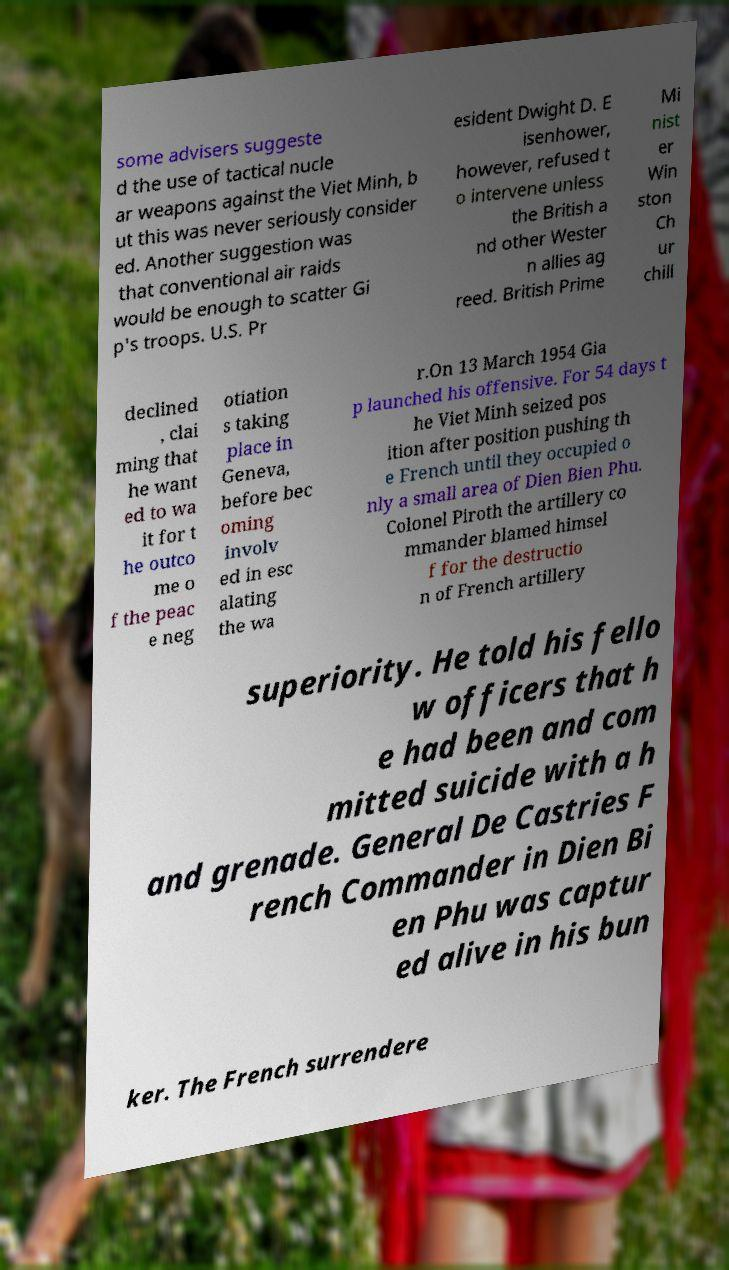What messages or text are displayed in this image? I need them in a readable, typed format. some advisers suggeste d the use of tactical nucle ar weapons against the Viet Minh, b ut this was never seriously consider ed. Another suggestion was that conventional air raids would be enough to scatter Gi p's troops. U.S. Pr esident Dwight D. E isenhower, however, refused t o intervene unless the British a nd other Wester n allies ag reed. British Prime Mi nist er Win ston Ch ur chill declined , clai ming that he want ed to wa it for t he outco me o f the peac e neg otiation s taking place in Geneva, before bec oming involv ed in esc alating the wa r.On 13 March 1954 Gia p launched his offensive. For 54 days t he Viet Minh seized pos ition after position pushing th e French until they occupied o nly a small area of Dien Bien Phu. Colonel Piroth the artillery co mmander blamed himsel f for the destructio n of French artillery superiority. He told his fello w officers that h e had been and com mitted suicide with a h and grenade. General De Castries F rench Commander in Dien Bi en Phu was captur ed alive in his bun ker. The French surrendere 